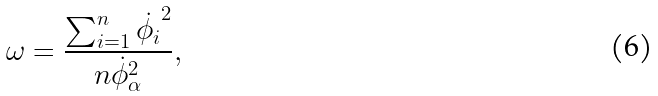<formula> <loc_0><loc_0><loc_500><loc_500>\omega = \frac { \sum _ { i = 1 } ^ { n } \dot { \phi _ { i } } ^ { 2 } } { n \dot { \phi } _ { \alpha } ^ { 2 } } ,</formula> 